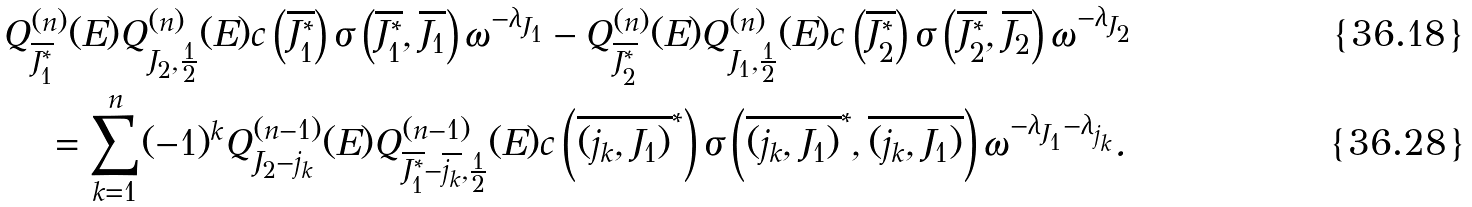Convert formula to latex. <formula><loc_0><loc_0><loc_500><loc_500>Q ^ { ( n ) } _ { \overline { J ^ { * } _ { 1 } } } ( E ) Q ^ { ( n ) } _ { J _ { 2 } , \frac { 1 } { 2 } } ( E ) c \left ( \overline { J ^ { * } _ { 1 } } \right ) \sigma \left ( \overline { J ^ { * } _ { 1 } } , \overline { J _ { 1 } } \right ) \omega ^ { - \lambda _ { J _ { 1 } } } - Q ^ { ( n ) } _ { \overline { J ^ { * } _ { 2 } } } ( E ) Q ^ { ( n ) } _ { J _ { 1 } , \frac { 1 } { 2 } } ( E ) c \left ( \overline { J ^ { * } _ { 2 } } \right ) \sigma \left ( \overline { J ^ { * } _ { 2 } } , \overline { J _ { 2 } } \right ) \omega ^ { - \lambda _ { J _ { 2 } } } \\ = \sum ^ { n } _ { k = 1 } ( - 1 ) ^ { k } Q ^ { ( n - 1 ) } _ { J _ { 2 } - j _ { k } } ( E ) Q ^ { ( n - 1 ) } _ { \overline { J ^ { * } _ { 1 } } - \overline { j _ { k } } , \frac { 1 } { 2 } } ( E ) c \left ( \overline { ( j _ { k } , J _ { 1 } ) } ^ { * } \right ) \sigma \left ( \overline { ( j _ { k } , J _ { 1 } ) } ^ { * } , \overline { ( j _ { k } , J _ { 1 } ) } \right ) \omega ^ { - \lambda _ { J _ { 1 } } - \lambda _ { j _ { k } } } . \,</formula> 